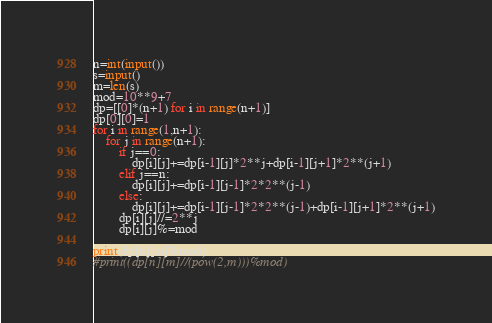Convert code to text. <code><loc_0><loc_0><loc_500><loc_500><_Python_>n=int(input())
s=input()
m=len(s)
mod=10**9+7
dp=[[0]*(n+1) for i in range(n+1)]
dp[0][0]=1
for i in range(1,n+1):
    for j in range(n+1):
        if j==0:
            dp[i][j]+=dp[i-1][j]*2**j+dp[i-1][j+1]*2**(j+1)
        elif j==n:
            dp[i][j]+=dp[i-1][j-1]*2*2**(j-1)
        else:
            dp[i][j]+=dp[i-1][j-1]*2*2**(j-1)+dp[i-1][j+1]*2**(j+1)
        dp[i][j]//=2**j
        dp[i][j]%=mod

print(dp[n][m]%mod)
#print((dp[n][m]//(pow(2,m)))%mod)




</code> 